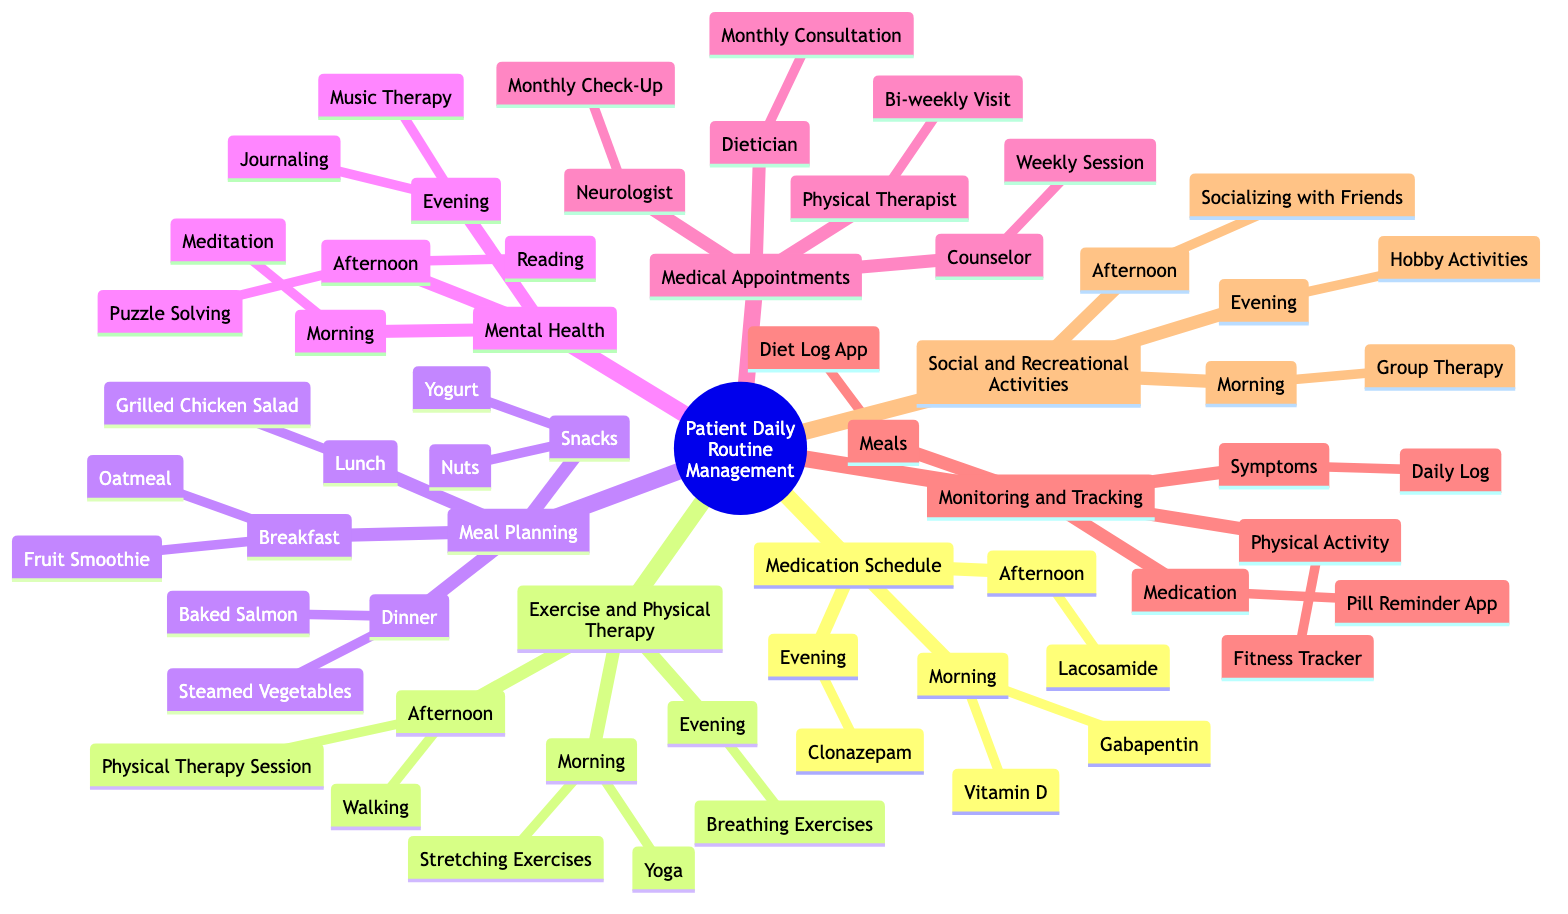What medications are taken in the morning? The morning medications are listed under the "Medication Schedule" branch in the diagram. Specifically, they are "Gabapentin" and "Vitamin D."
Answer: Gabapentin, Vitamin D How many types of exercises are scheduled in the afternoon? The diagram shows two activities under the "Exercise and Physical Therapy" branch for the afternoon: "Walking" and "Physical Therapy Session." Counting these gives a total of two activities.
Answer: 2 What is the frequency of the counselor appointments? Under the "Medical Appointments" section, the counselor has a "Weekly Session," which indicates that the appointments occur once a week.
Answer: Weekly Which meal includes nuts? The "Snacks" section listed under "Meal Planning" contains "Nuts." Thus, this is the meal that includes nuts.
Answer: Snacks Which activity is scheduled in the evening for mental health? The "Mental Health" section contains "Journaling" and "Music Therapy" under the evening category. Therefore, both activities are scheduled in the evening.
Answer: Journaling, Music Therapy How often are physical therapy sessions conducted? The "Physical Therapist" node within "Medical Appointments" indicates a "Bi-weekly Visit," meaning the sessions occur every two weeks.
Answer: Bi-weekly What is tracked using a fitness tracker? The "Monitoring and Tracking" section specifies that "Physical Activity" is the aspect that is monitored using a fitness tracker.
Answer: Physical Activity How many meals are planned for breakfast? The "Meal Planning" section under "Breakfast" includes two items: "Oatmeal" and "Fruit Smoothie." Hence, two items are planned for breakfast.
Answer: 2 Which time of day includes group therapy? The "Social and Recreational Activities" branch lists "Group Therapy" under the morning category. This shows that the activity occurs in the morning.
Answer: Morning 